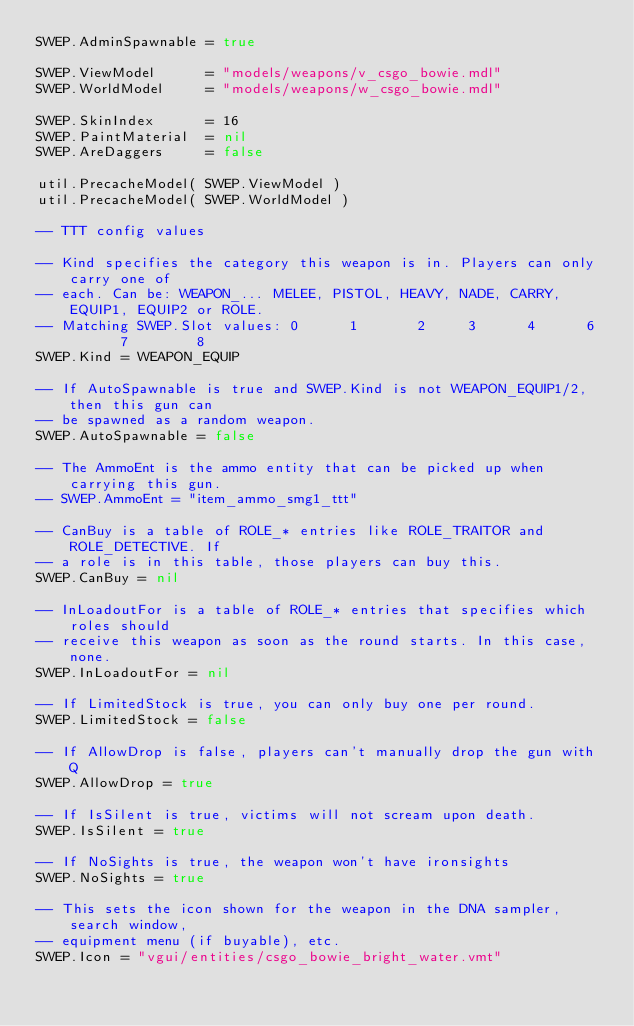<code> <loc_0><loc_0><loc_500><loc_500><_Lua_>SWEP.AdminSpawnable = true

SWEP.ViewModel      = "models/weapons/v_csgo_bowie.mdl"
SWEP.WorldModel     = "models/weapons/w_csgo_bowie.mdl"

SWEP.SkinIndex      = 16
SWEP.PaintMaterial  = nil
SWEP.AreDaggers     = false

util.PrecacheModel( SWEP.ViewModel )
util.PrecacheModel( SWEP.WorldModel )

-- TTT config values

-- Kind specifies the category this weapon is in. Players can only carry one of
-- each. Can be: WEAPON_... MELEE, PISTOL, HEAVY, NADE, CARRY, EQUIP1, EQUIP2 or ROLE.
-- Matching SWEP.Slot values: 0      1       2     3      4      6       7        8
SWEP.Kind = WEAPON_EQUIP

-- If AutoSpawnable is true and SWEP.Kind is not WEAPON_EQUIP1/2, then this gun can
-- be spawned as a random weapon.
SWEP.AutoSpawnable = false

-- The AmmoEnt is the ammo entity that can be picked up when carrying this gun.
-- SWEP.AmmoEnt = "item_ammo_smg1_ttt"

-- CanBuy is a table of ROLE_* entries like ROLE_TRAITOR and ROLE_DETECTIVE. If
-- a role is in this table, those players can buy this.
SWEP.CanBuy = nil

-- InLoadoutFor is a table of ROLE_* entries that specifies which roles should
-- receive this weapon as soon as the round starts. In this case, none.
SWEP.InLoadoutFor = nil

-- If LimitedStock is true, you can only buy one per round.
SWEP.LimitedStock = false

-- If AllowDrop is false, players can't manually drop the gun with Q
SWEP.AllowDrop = true

-- If IsSilent is true, victims will not scream upon death.
SWEP.IsSilent = true

-- If NoSights is true, the weapon won't have ironsights
SWEP.NoSights = true

-- This sets the icon shown for the weapon in the DNA sampler, search window,
-- equipment menu (if buyable), etc.
SWEP.Icon = "vgui/entities/csgo_bowie_bright_water.vmt"
</code> 